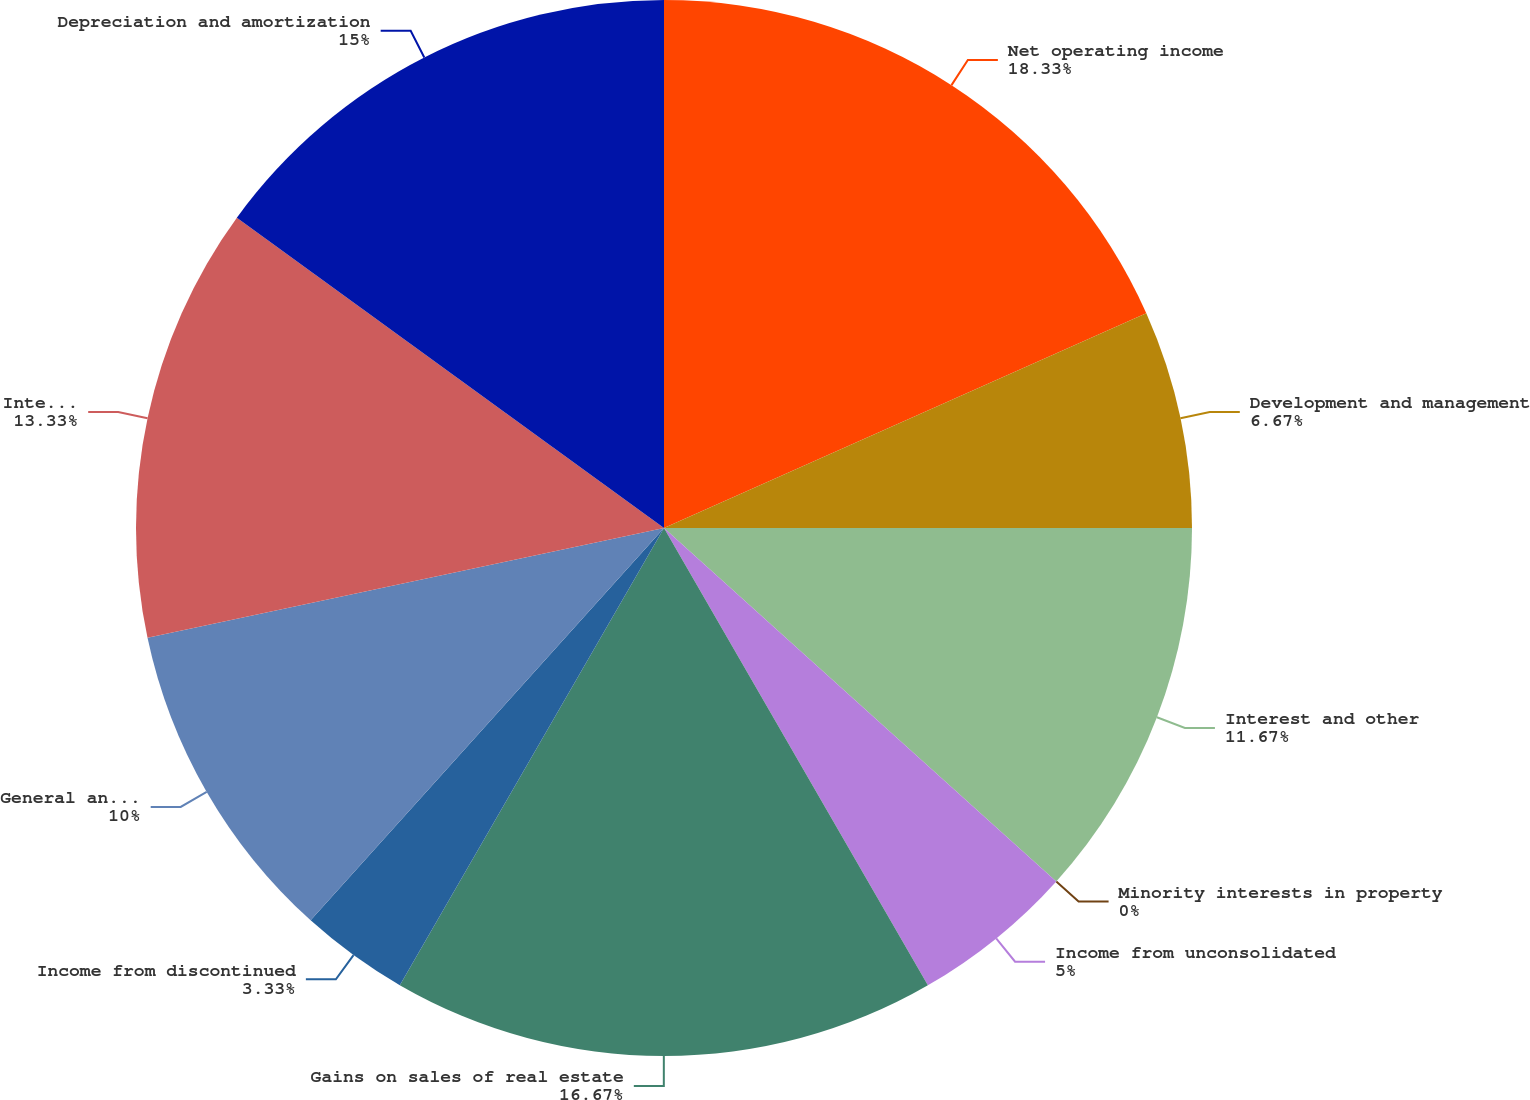<chart> <loc_0><loc_0><loc_500><loc_500><pie_chart><fcel>Net operating income<fcel>Development and management<fcel>Interest and other<fcel>Minority interests in property<fcel>Income from unconsolidated<fcel>Gains on sales of real estate<fcel>Income from discontinued<fcel>General and administrative<fcel>Interest expense<fcel>Depreciation and amortization<nl><fcel>18.33%<fcel>6.67%<fcel>11.67%<fcel>0.0%<fcel>5.0%<fcel>16.67%<fcel>3.33%<fcel>10.0%<fcel>13.33%<fcel>15.0%<nl></chart> 